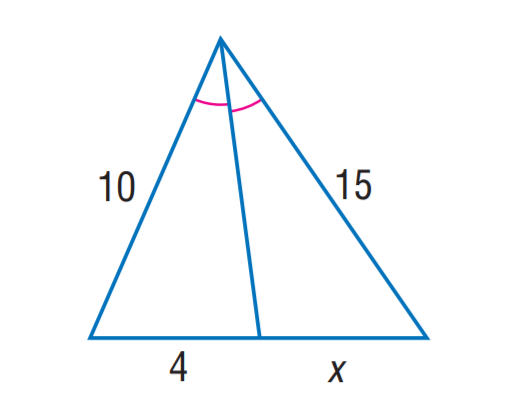Answer the mathemtical geometry problem and directly provide the correct option letter.
Question: Find x.
Choices: A: 4 B: 6 C: 8 D: 12 B 